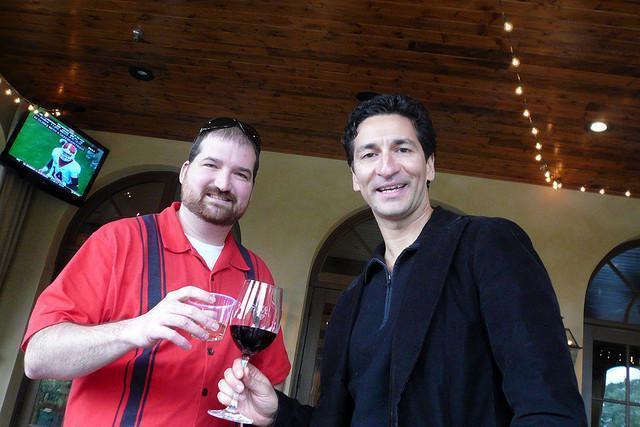How many guys are in the photo?
Give a very brief answer. 2. How many people are there?
Give a very brief answer. 2. How many boats are there?
Give a very brief answer. 0. 